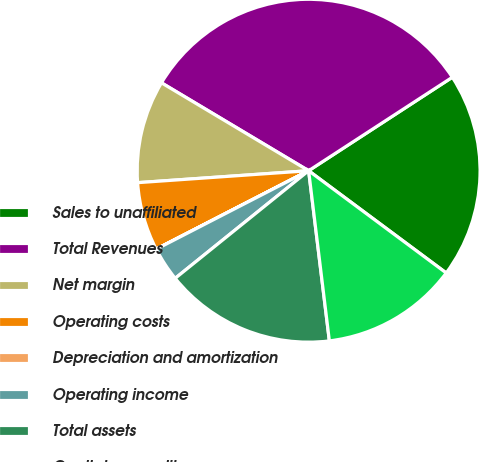Convert chart to OTSL. <chart><loc_0><loc_0><loc_500><loc_500><pie_chart><fcel>Sales to unaffiliated<fcel>Total Revenues<fcel>Net margin<fcel>Operating costs<fcel>Depreciation and amortization<fcel>Operating income<fcel>Total assets<fcel>Capital expenditures<nl><fcel>19.35%<fcel>32.25%<fcel>9.68%<fcel>6.45%<fcel>0.01%<fcel>3.23%<fcel>16.13%<fcel>12.9%<nl></chart> 